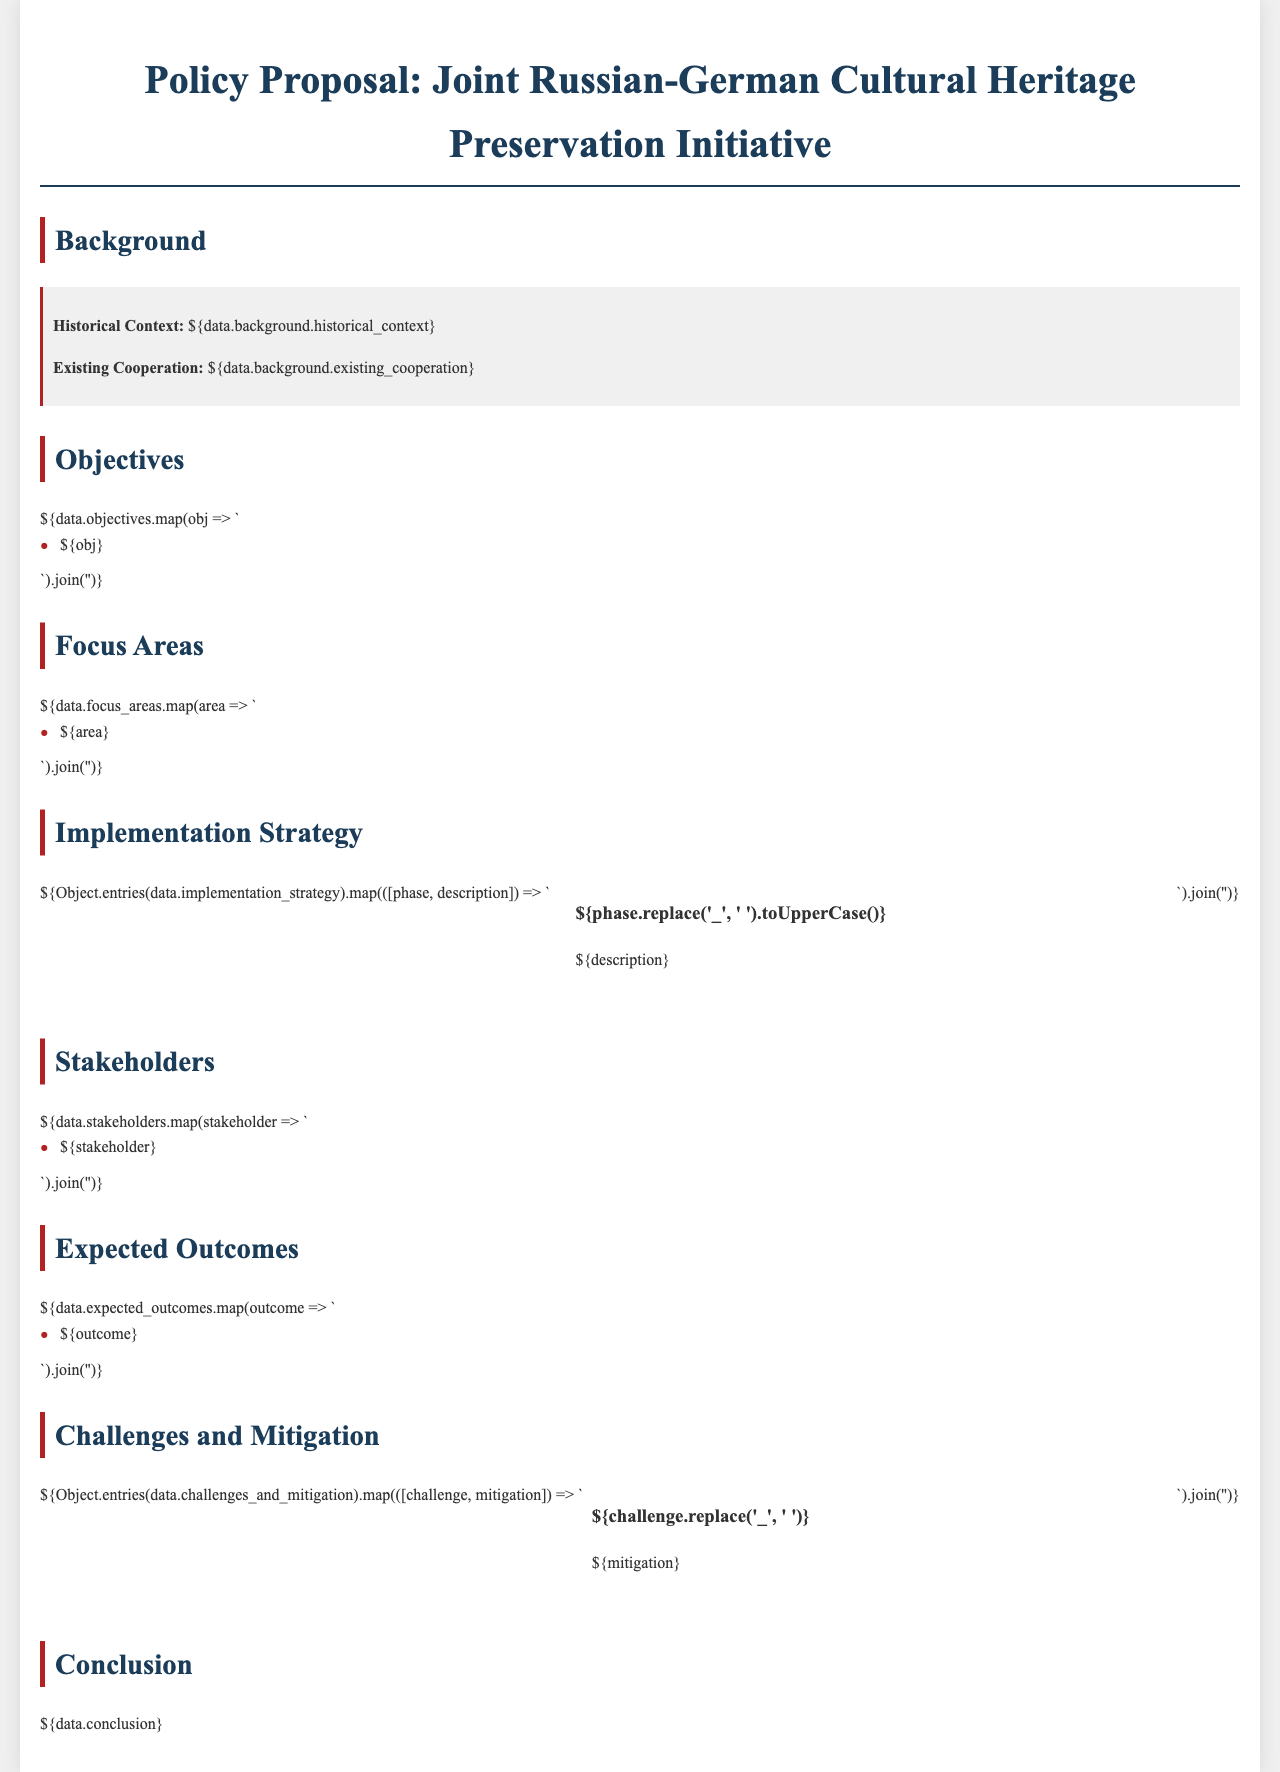What is the title of the proposal? The title of the proposal is mentioned at the top of the document.
Answer: Joint Russian-German Cultural Heritage Preservation Initiative What is one focus area listed in the document? The document outlines specific focus areas to be preserved.
Answer: Shared historical sites Who are the stakeholders mentioned in the initiative? Stakeholders are identified as essential participants in the initiative.
Answer: Various cultural institutions What is the purpose of the implementation strategy? The implementation strategy describes how the proposal will be actualized step-by-step.
Answer: Preserve cultural heritage What is one challenge outlined in the document? The document identifies challenges that might impede the proposal's success.
Answer: Limited funding What is the expected outcome of the initiative? The outcomes illustrate the anticipated results of the proposal.
Answer: Improved cultural exchange In how many phases is the implementation strategy divided? The implementation strategy likely distinguishes various phases for clarity and organization.
Answer: Multiple phases What is the historical context mentioned in the background? Historical context provides the reader with relevant background information about the initiative's origin.
Answer: Complex relationships What is a mitigation strategy for the challenges? Part of the section on challenges includes measures to address potential issues.
Answer: Increased collaboration 